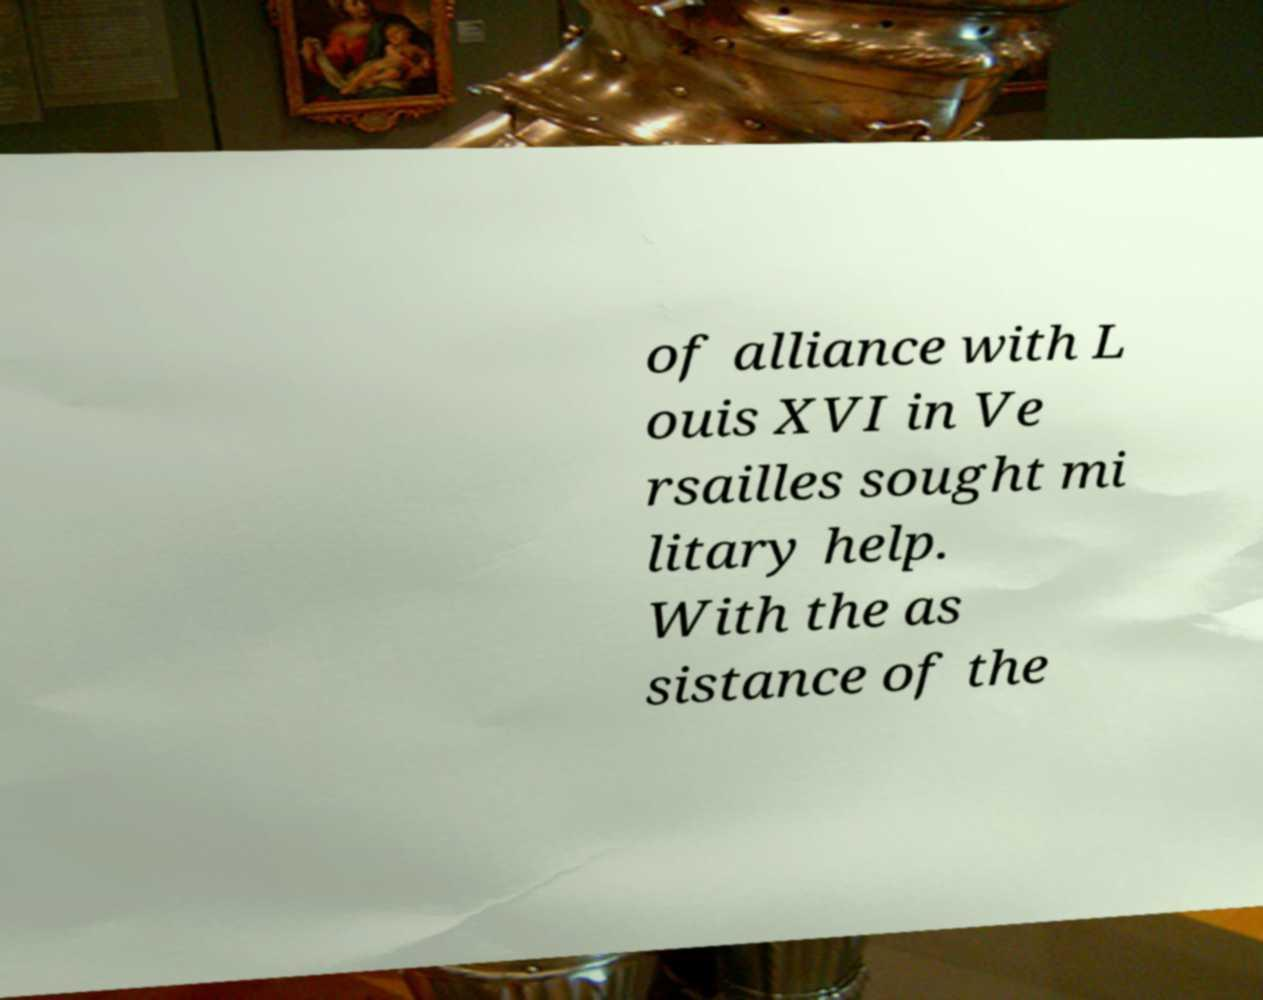Can you read and provide the text displayed in the image?This photo seems to have some interesting text. Can you extract and type it out for me? of alliance with L ouis XVI in Ve rsailles sought mi litary help. With the as sistance of the 